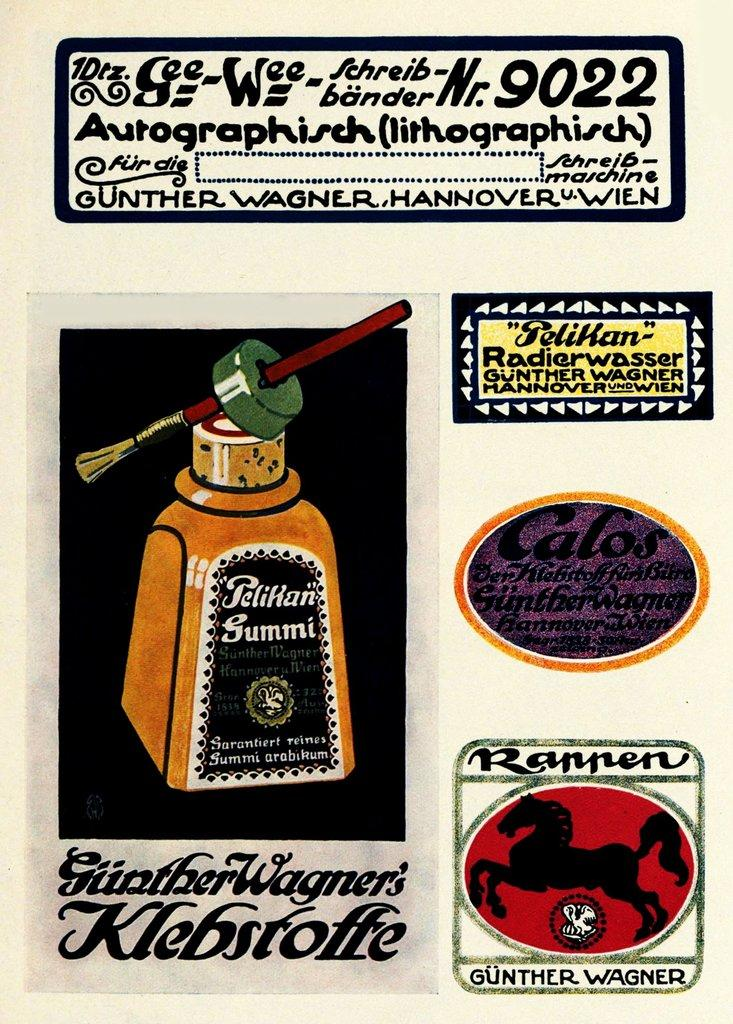What is present in the image that contains both text and paintings? There is a poster in the image that contains text and paintings. Can you describe the poster in more detail? The poster contains text and paintings, which suggests it might be an advertisement or informational material. What type of basket is hanging from the poster in the image? There is no basket present in the image. 